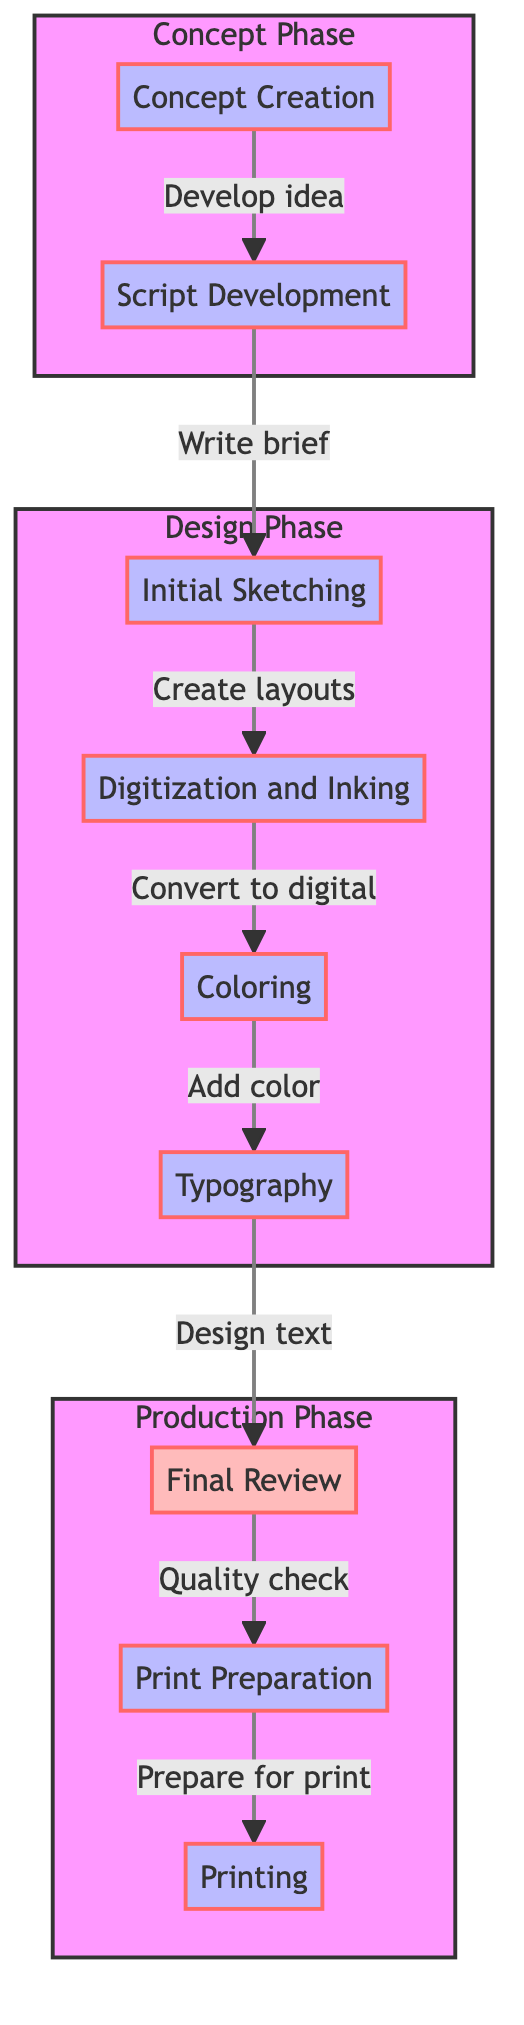What is the first stage of the comic book cover creation process? The first stage is indicated as "Concept Creation" in the diagram.
Answer: Concept Creation How many stages are there in total for creating a comic book cover? By counting the stages listed in the diagram, there are a total of 8 stages from "Concept Creation" to "Printing."
Answer: 8 What stage comes after 'Coloring'? The next stage indicated after 'Coloring' is 'Typography,' which follows the color application step in the flowchart.
Answer: Typography Which stage focuses on quality checks? The stage that emphasizes quality checking is "Final Review," as detailed in its description related to performing quality checks for errors.
Answer: Final Review In which phase is 'Initial Sketching' located? 'Initial Sketching' is part of the 'Design Phase,' as indicated by the subgraph that groups it with other design activities.
Answer: Design Phase What is the last step before printing the final covers? The last step before actual printing is 'Print Preparation,' which includes finalizing all details and converting designs to the correct format for printing.
Answer: Print Preparation What task is involved in 'Digitization and Inking'? In the 'Digitization and Inking' stage, the task involves converting the final sketch into a digital format and beginning the inking process.
Answer: Convert to digital What is a key task during the 'Script Development' stage? A key task in the 'Script Development' stage is to outline main plot points and characters, which helps guide the cover design.
Answer: Outline main plot points and characters How does the flow of the stages transition from 'Graphical' to 'Production'? The flow of the stages moves from 'Graphical' aspects like 'Final Review' into the 'Production' phase where the final design preparation and printing occur, highlighting a shift from design to production work.
Answer: From 'Final Review' to 'Production' 